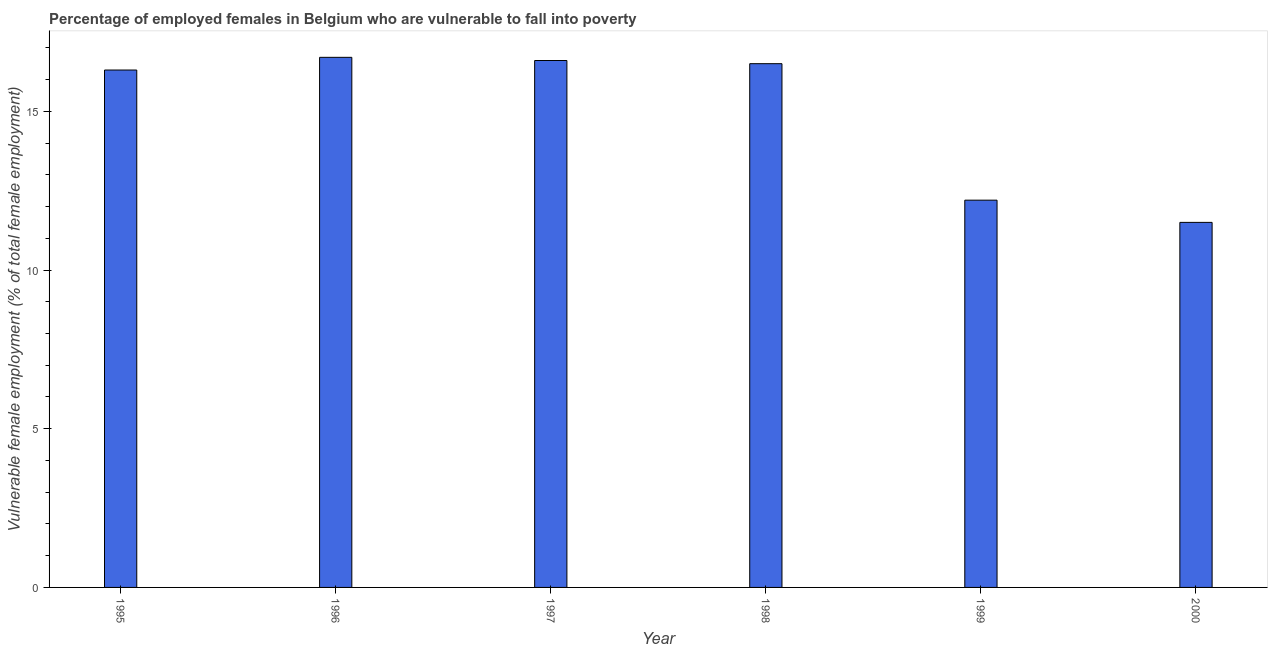Does the graph contain any zero values?
Your answer should be very brief. No. Does the graph contain grids?
Your response must be concise. No. What is the title of the graph?
Keep it short and to the point. Percentage of employed females in Belgium who are vulnerable to fall into poverty. What is the label or title of the X-axis?
Your answer should be very brief. Year. What is the label or title of the Y-axis?
Give a very brief answer. Vulnerable female employment (% of total female employment). Across all years, what is the maximum percentage of employed females who are vulnerable to fall into poverty?
Your answer should be compact. 16.7. Across all years, what is the minimum percentage of employed females who are vulnerable to fall into poverty?
Make the answer very short. 11.5. In which year was the percentage of employed females who are vulnerable to fall into poverty minimum?
Make the answer very short. 2000. What is the sum of the percentage of employed females who are vulnerable to fall into poverty?
Make the answer very short. 89.8. What is the difference between the percentage of employed females who are vulnerable to fall into poverty in 1999 and 2000?
Your answer should be very brief. 0.7. What is the average percentage of employed females who are vulnerable to fall into poverty per year?
Your response must be concise. 14.97. What is the median percentage of employed females who are vulnerable to fall into poverty?
Offer a very short reply. 16.4. Do a majority of the years between 1999 and 1997 (inclusive) have percentage of employed females who are vulnerable to fall into poverty greater than 4 %?
Provide a short and direct response. Yes. What is the ratio of the percentage of employed females who are vulnerable to fall into poverty in 1998 to that in 1999?
Your response must be concise. 1.35. Is the percentage of employed females who are vulnerable to fall into poverty in 1996 less than that in 1999?
Offer a terse response. No. What is the difference between the highest and the second highest percentage of employed females who are vulnerable to fall into poverty?
Keep it short and to the point. 0.1. In how many years, is the percentage of employed females who are vulnerable to fall into poverty greater than the average percentage of employed females who are vulnerable to fall into poverty taken over all years?
Your answer should be very brief. 4. How many bars are there?
Provide a short and direct response. 6. Are all the bars in the graph horizontal?
Make the answer very short. No. What is the difference between two consecutive major ticks on the Y-axis?
Make the answer very short. 5. What is the Vulnerable female employment (% of total female employment) of 1995?
Provide a short and direct response. 16.3. What is the Vulnerable female employment (% of total female employment) in 1996?
Provide a short and direct response. 16.7. What is the Vulnerable female employment (% of total female employment) of 1997?
Provide a succinct answer. 16.6. What is the Vulnerable female employment (% of total female employment) of 1998?
Your answer should be compact. 16.5. What is the Vulnerable female employment (% of total female employment) of 1999?
Provide a short and direct response. 12.2. What is the Vulnerable female employment (% of total female employment) of 2000?
Your answer should be compact. 11.5. What is the difference between the Vulnerable female employment (% of total female employment) in 1995 and 1996?
Your response must be concise. -0.4. What is the difference between the Vulnerable female employment (% of total female employment) in 1995 and 1998?
Your response must be concise. -0.2. What is the difference between the Vulnerable female employment (% of total female employment) in 1995 and 1999?
Your answer should be very brief. 4.1. What is the difference between the Vulnerable female employment (% of total female employment) in 1995 and 2000?
Ensure brevity in your answer.  4.8. What is the difference between the Vulnerable female employment (% of total female employment) in 1996 and 1997?
Make the answer very short. 0.1. What is the difference between the Vulnerable female employment (% of total female employment) in 1996 and 1999?
Provide a succinct answer. 4.5. What is the difference between the Vulnerable female employment (% of total female employment) in 1996 and 2000?
Offer a terse response. 5.2. What is the difference between the Vulnerable female employment (% of total female employment) in 1997 and 1998?
Your answer should be very brief. 0.1. What is the difference between the Vulnerable female employment (% of total female employment) in 1997 and 1999?
Ensure brevity in your answer.  4.4. What is the difference between the Vulnerable female employment (% of total female employment) in 1997 and 2000?
Your answer should be very brief. 5.1. What is the difference between the Vulnerable female employment (% of total female employment) in 1998 and 1999?
Your answer should be very brief. 4.3. What is the difference between the Vulnerable female employment (% of total female employment) in 1998 and 2000?
Offer a very short reply. 5. What is the difference between the Vulnerable female employment (% of total female employment) in 1999 and 2000?
Your answer should be compact. 0.7. What is the ratio of the Vulnerable female employment (% of total female employment) in 1995 to that in 1996?
Your response must be concise. 0.98. What is the ratio of the Vulnerable female employment (% of total female employment) in 1995 to that in 1997?
Offer a terse response. 0.98. What is the ratio of the Vulnerable female employment (% of total female employment) in 1995 to that in 1999?
Give a very brief answer. 1.34. What is the ratio of the Vulnerable female employment (% of total female employment) in 1995 to that in 2000?
Provide a short and direct response. 1.42. What is the ratio of the Vulnerable female employment (% of total female employment) in 1996 to that in 1997?
Your response must be concise. 1.01. What is the ratio of the Vulnerable female employment (% of total female employment) in 1996 to that in 1998?
Provide a short and direct response. 1.01. What is the ratio of the Vulnerable female employment (% of total female employment) in 1996 to that in 1999?
Your answer should be compact. 1.37. What is the ratio of the Vulnerable female employment (% of total female employment) in 1996 to that in 2000?
Provide a short and direct response. 1.45. What is the ratio of the Vulnerable female employment (% of total female employment) in 1997 to that in 1998?
Offer a terse response. 1.01. What is the ratio of the Vulnerable female employment (% of total female employment) in 1997 to that in 1999?
Offer a very short reply. 1.36. What is the ratio of the Vulnerable female employment (% of total female employment) in 1997 to that in 2000?
Give a very brief answer. 1.44. What is the ratio of the Vulnerable female employment (% of total female employment) in 1998 to that in 1999?
Your response must be concise. 1.35. What is the ratio of the Vulnerable female employment (% of total female employment) in 1998 to that in 2000?
Ensure brevity in your answer.  1.44. What is the ratio of the Vulnerable female employment (% of total female employment) in 1999 to that in 2000?
Your response must be concise. 1.06. 